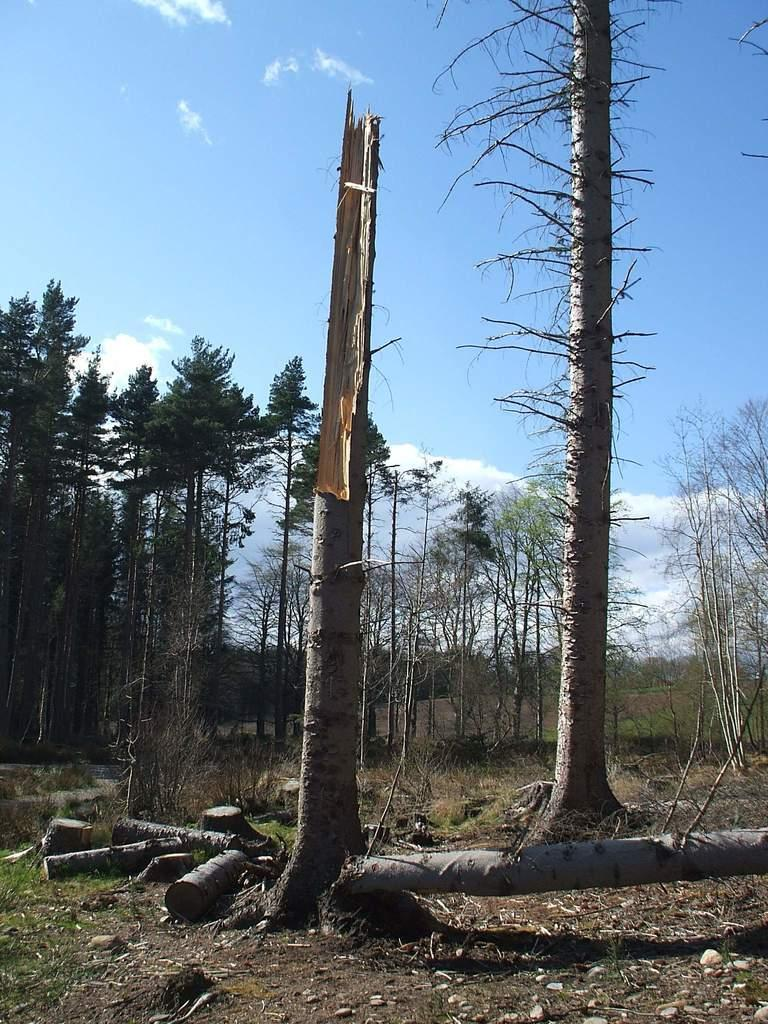What is the main feature of the image? There is a tree trunk in the image. What other wooden objects can be seen in the image? There are wooden logs in the image. What type of vegetation is present in the image? There are plants and trees in the image. What is the ground covered with in the image? There is grass in the image. What can be seen in the background of the image? The sky is visible in the background of the image. What type of dirt can be seen on the jeans in the image? There are no jeans present in the image, so it is not possible to determine if there is any dirt on them. 